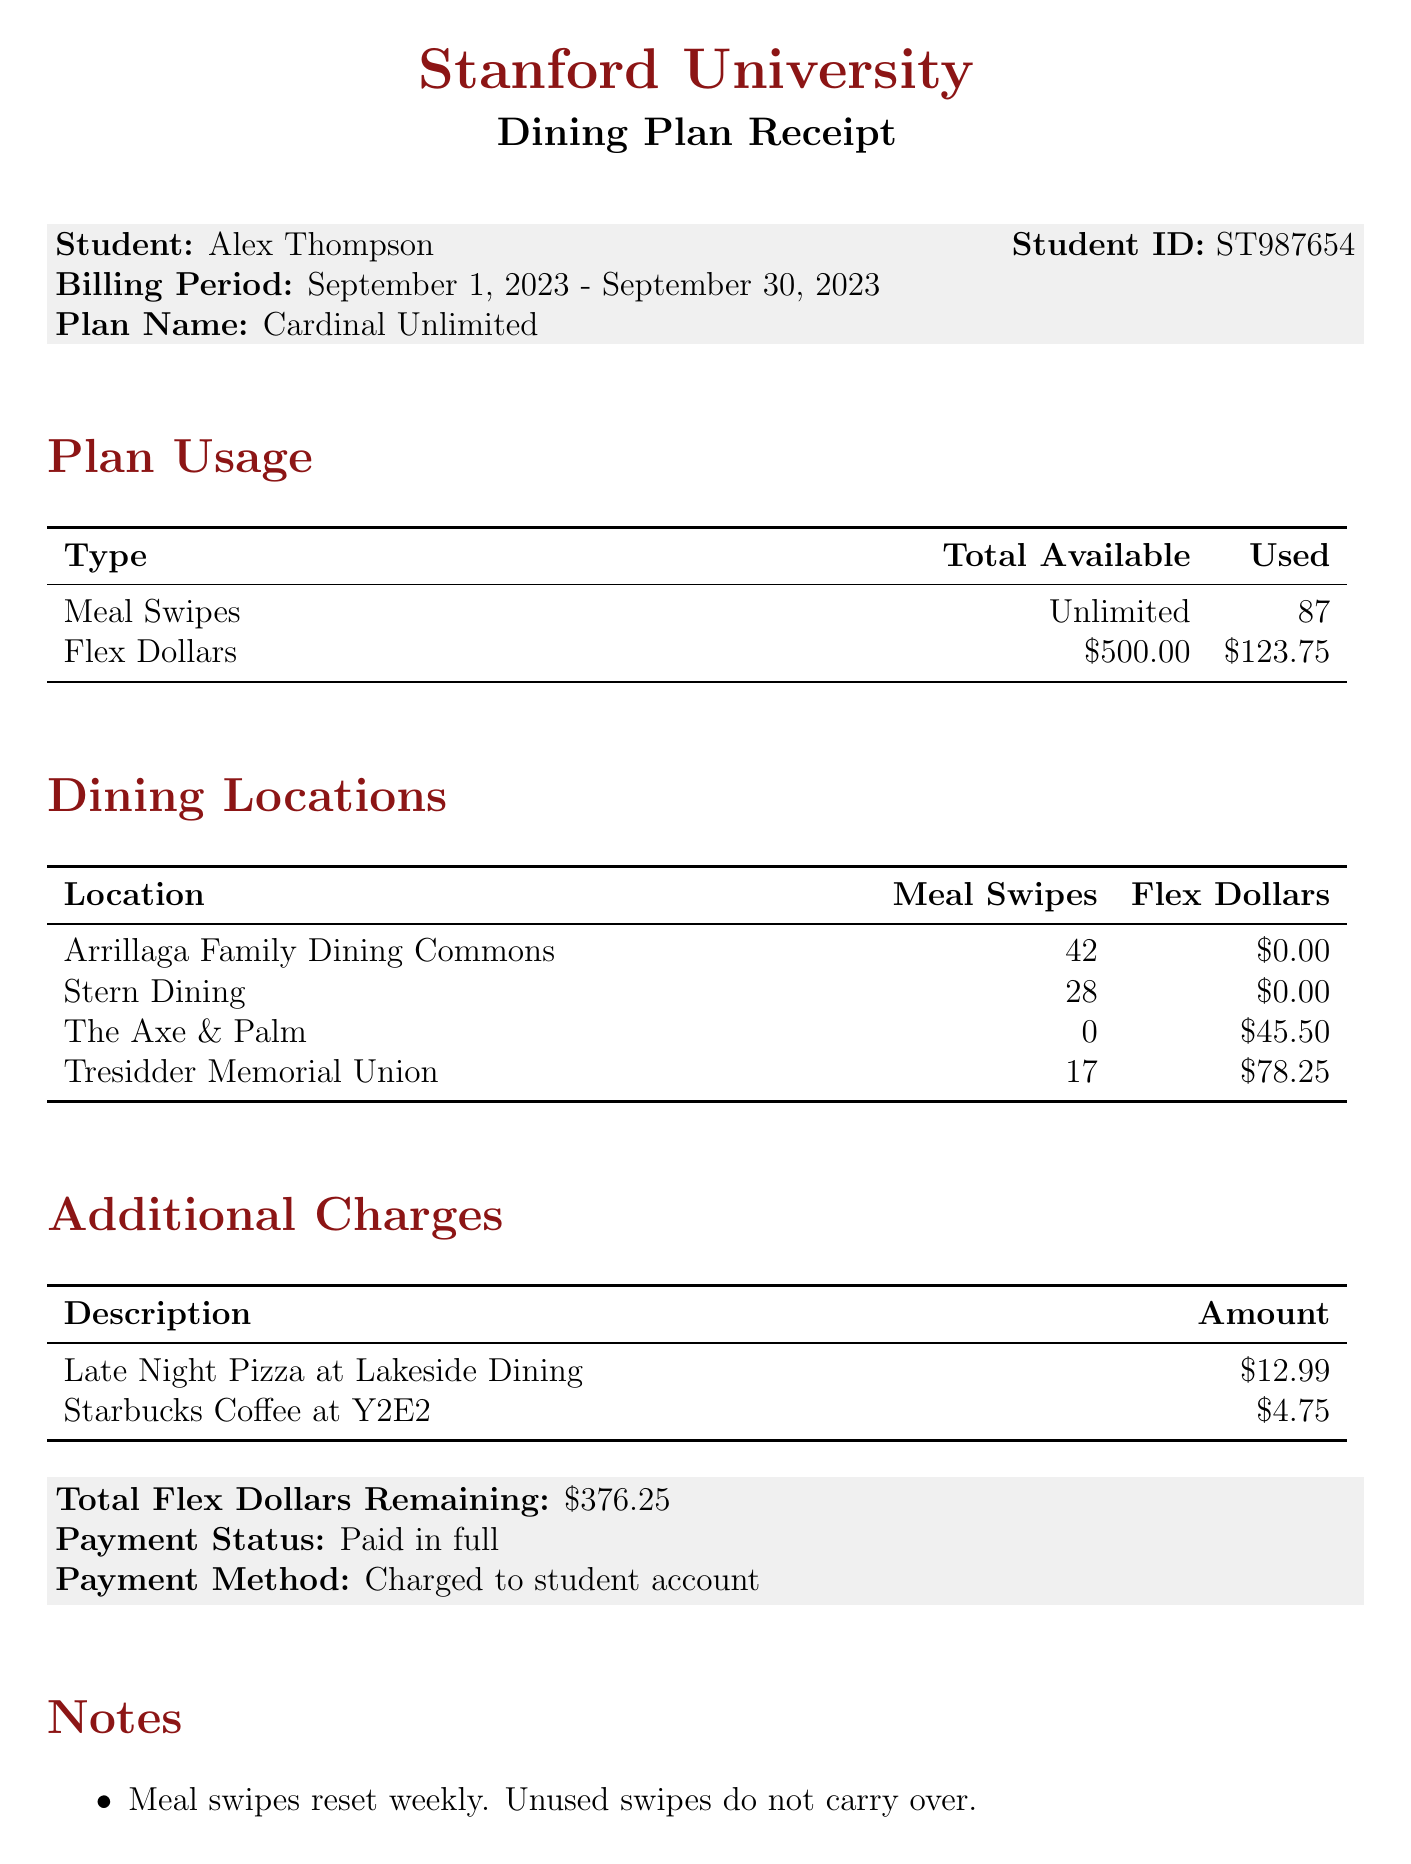what is the university name? The university name is clearly stated at the top of the document.
Answer: Stanford University who is the student? The student name is listed on the receipt section of the document.
Answer: Alex Thompson what is the billing period? The billing period is mentioned under the student's information section.
Answer: September 1, 2023 - September 30, 2023 how many meal swipes have been used? The number of meal swipes used is indicated in the plan usage section.
Answer: 87 what is the total amount of flex dollars used? The total flex dollars used is found in the plan usage section and corresponds to the used value.
Answer: 123.75 what are the names of the dining locations? The names of the dining locations are listed in the dining locations section of the document.
Answer: Arrillaga Family Dining Commons, Stern Dining, The Axe & Palm, Tresidder Memorial Union how much were the additional charges? Additional charges are outlined in their section, and the amounts are clearly listed.
Answer: 17.74 what is the remaining balance of flex dollars? The total flex dollars remaining is specified towards the end of the document.
Answer: 376.25 what is the payment status? The payment status is noted in the final summary section of the document.
Answer: Paid in full 